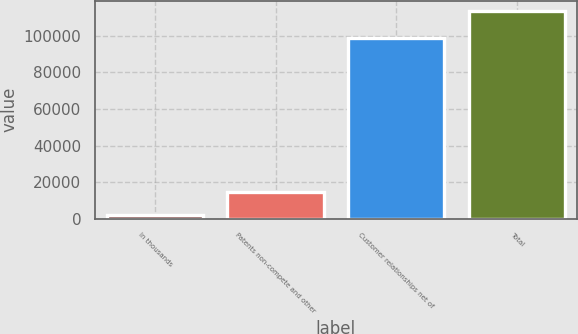<chart> <loc_0><loc_0><loc_500><loc_500><bar_chart><fcel>In thousands<fcel>Patents non-compete and other<fcel>Customer relationships net of<fcel>Total<nl><fcel>2010<fcel>14363<fcel>99039<fcel>113402<nl></chart> 